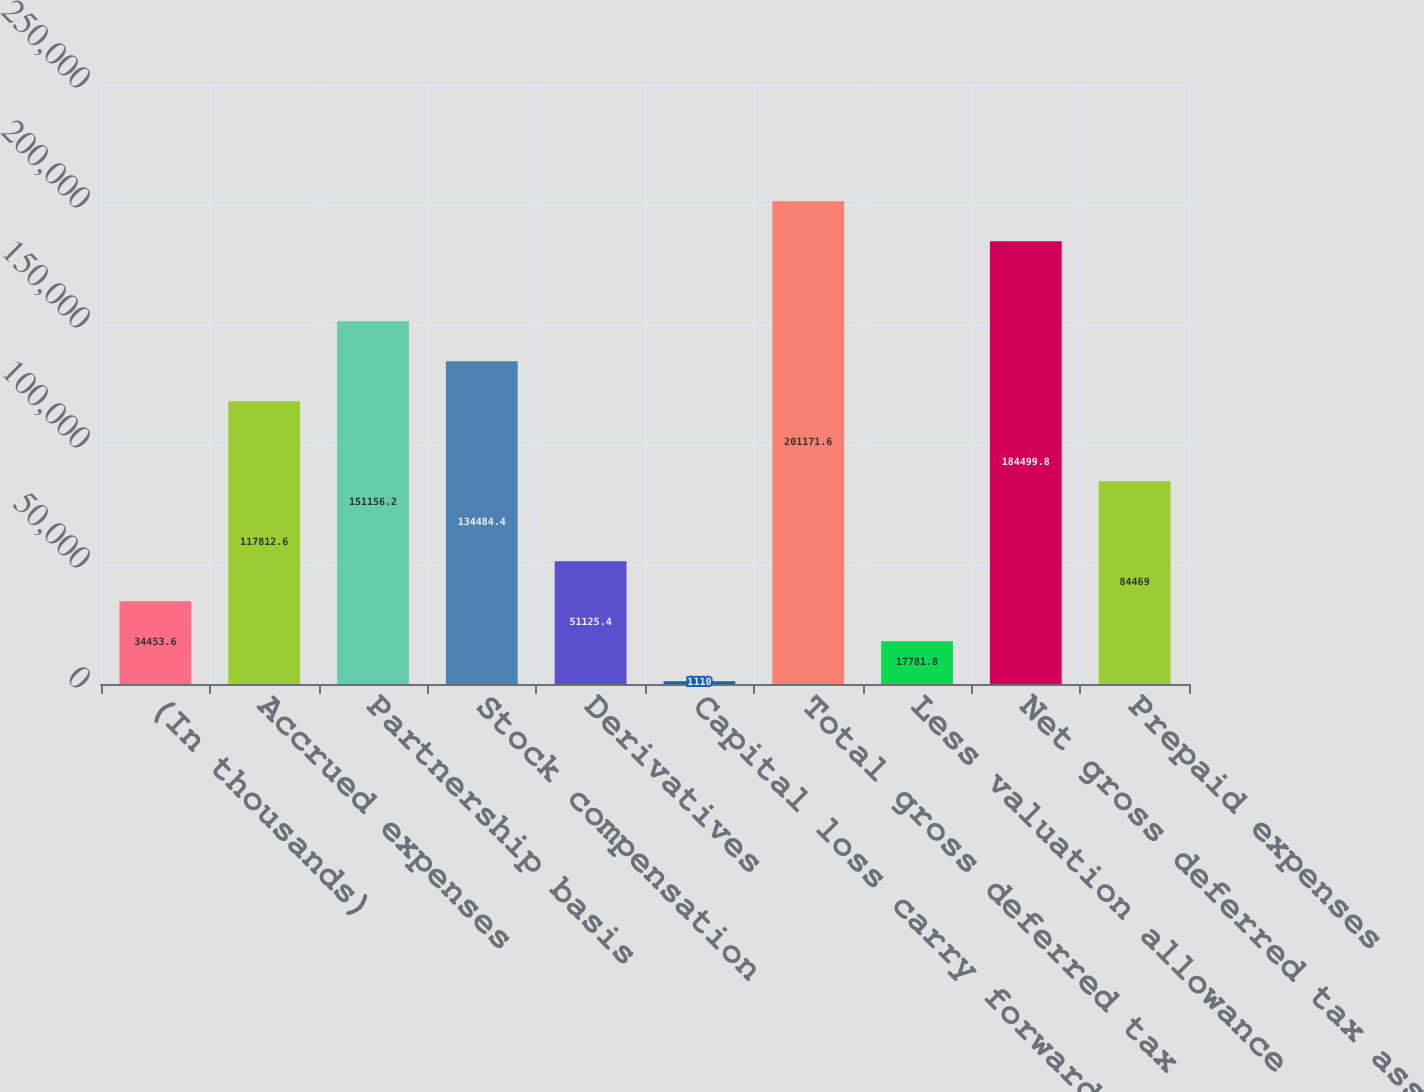Convert chart to OTSL. <chart><loc_0><loc_0><loc_500><loc_500><bar_chart><fcel>(In thousands)<fcel>Accrued expenses<fcel>Partnership basis<fcel>Stock compensation<fcel>Derivatives<fcel>Capital loss carry forward<fcel>Total gross deferred tax<fcel>Less valuation allowance<fcel>Net gross deferred tax assets<fcel>Prepaid expenses<nl><fcel>34453.6<fcel>117813<fcel>151156<fcel>134484<fcel>51125.4<fcel>1110<fcel>201172<fcel>17781.8<fcel>184500<fcel>84469<nl></chart> 